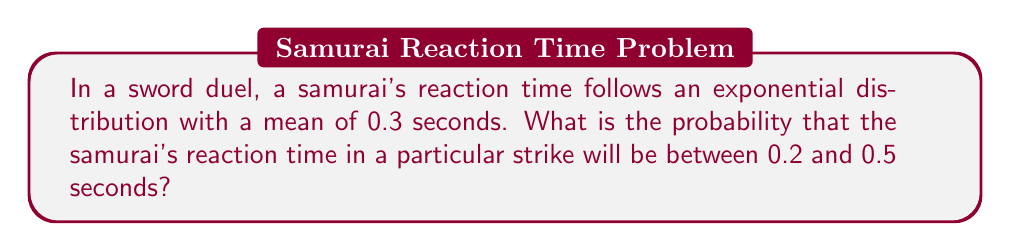Can you solve this math problem? Let's approach this step-by-step:

1) The reaction time follows an exponential distribution with mean $\mu = 0.3$ seconds.

2) For an exponential distribution, the rate parameter $\lambda = \frac{1}{\mu} = \frac{1}{0.3} \approx 3.33$ per second.

3) The cumulative distribution function (CDF) of an exponential distribution is:

   $F(x) = 1 - e^{-\lambda x}$

4) We need to find $P(0.2 < X < 0.5)$, which can be calculated as:

   $P(0.2 < X < 0.5) = F(0.5) - F(0.2)$

5) Let's calculate $F(0.5)$:
   
   $F(0.5) = 1 - e^{-3.33 * 0.5} \approx 0.8111$

6) Now, let's calculate $F(0.2)$:
   
   $F(0.2) = 1 - e^{-3.33 * 0.2} \approx 0.4866$

7) Therefore:

   $P(0.2 < X < 0.5) = F(0.5) - F(0.2) \approx 0.8111 - 0.4866 \approx 0.3245$
Answer: $0.3245$ or $32.45\%$ 